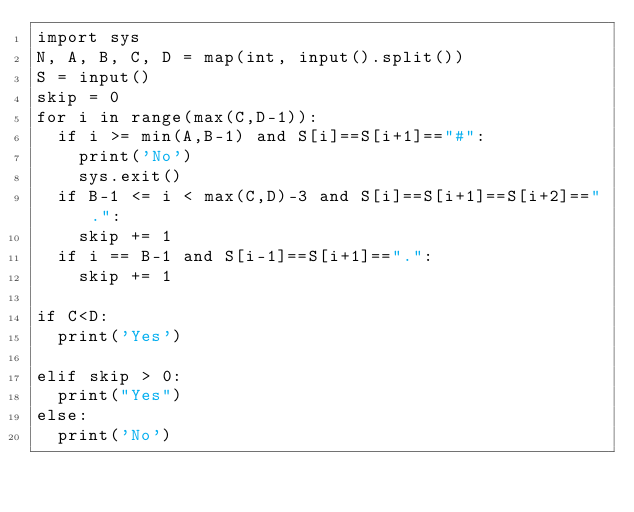Convert code to text. <code><loc_0><loc_0><loc_500><loc_500><_Python_>import sys
N, A, B, C, D = map(int, input().split())
S = input()
skip = 0
for i in range(max(C,D-1)):
	if i >= min(A,B-1) and S[i]==S[i+1]=="#":
		print('No')
		sys.exit()
	if B-1 <= i < max(C,D)-3 and S[i]==S[i+1]==S[i+2]==".":
		skip += 1
	if i == B-1 and S[i-1]==S[i+1]==".":
		skip += 1

if C<D:
	print('Yes')

elif skip > 0:
	print("Yes")
else:
	print('No')</code> 